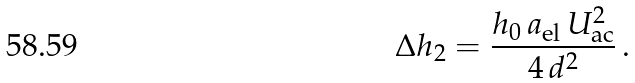<formula> <loc_0><loc_0><loc_500><loc_500>\Delta h _ { 2 } = \frac { h _ { 0 } \, a _ { \text {el} } \, U _ { \text {ac} } ^ { 2 } } { 4 \, d ^ { 2 } } \, .</formula> 